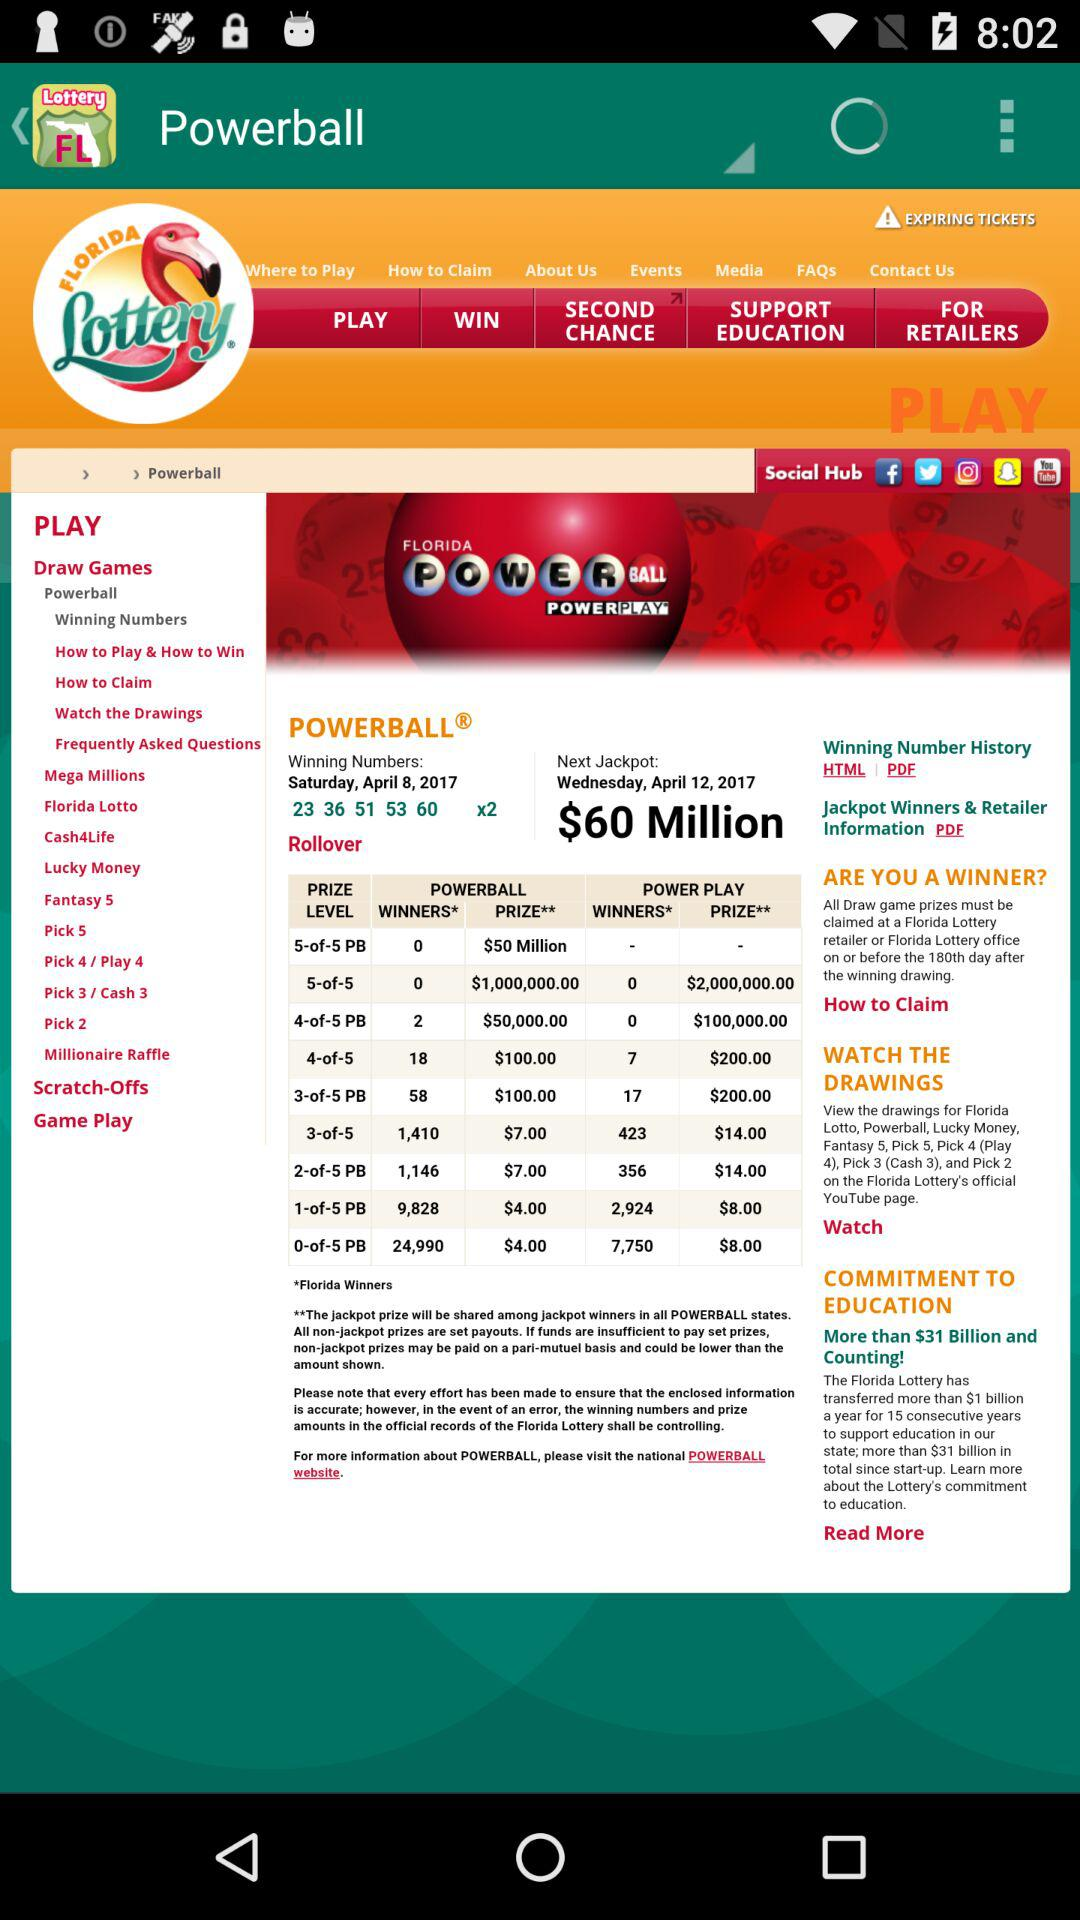What is the winning price for the jackpot? The winning prize is $60 million for the jackpot. 